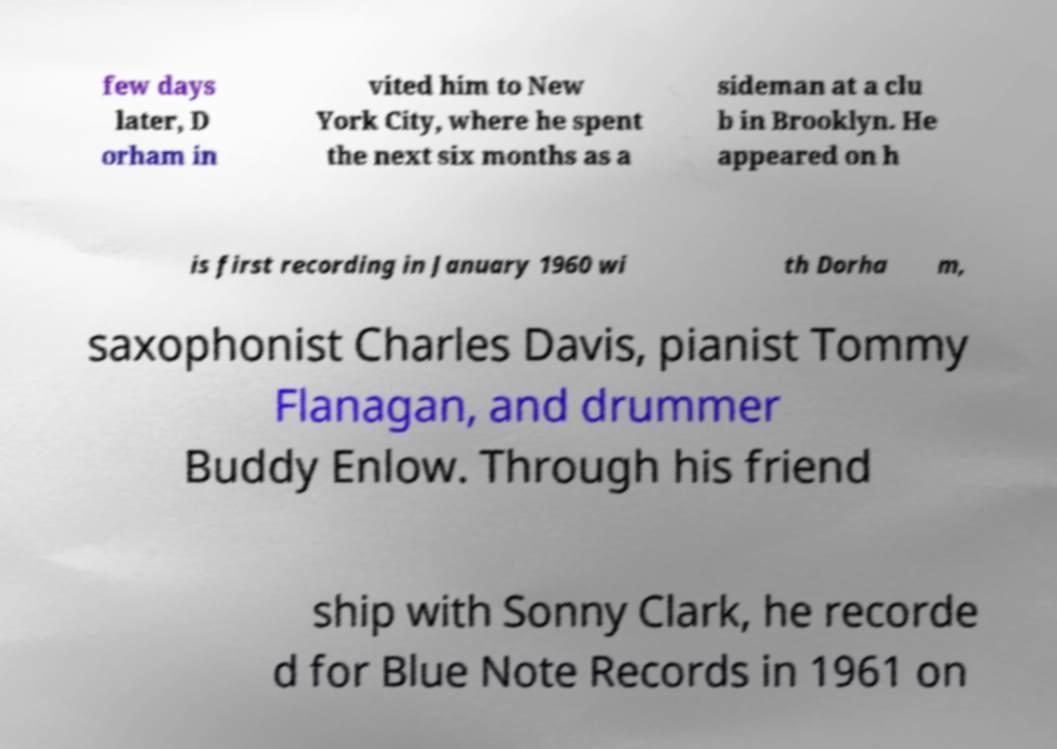Could you extract and type out the text from this image? few days later, D orham in vited him to New York City, where he spent the next six months as a sideman at a clu b in Brooklyn. He appeared on h is first recording in January 1960 wi th Dorha m, saxophonist Charles Davis, pianist Tommy Flanagan, and drummer Buddy Enlow. Through his friend ship with Sonny Clark, he recorde d for Blue Note Records in 1961 on 